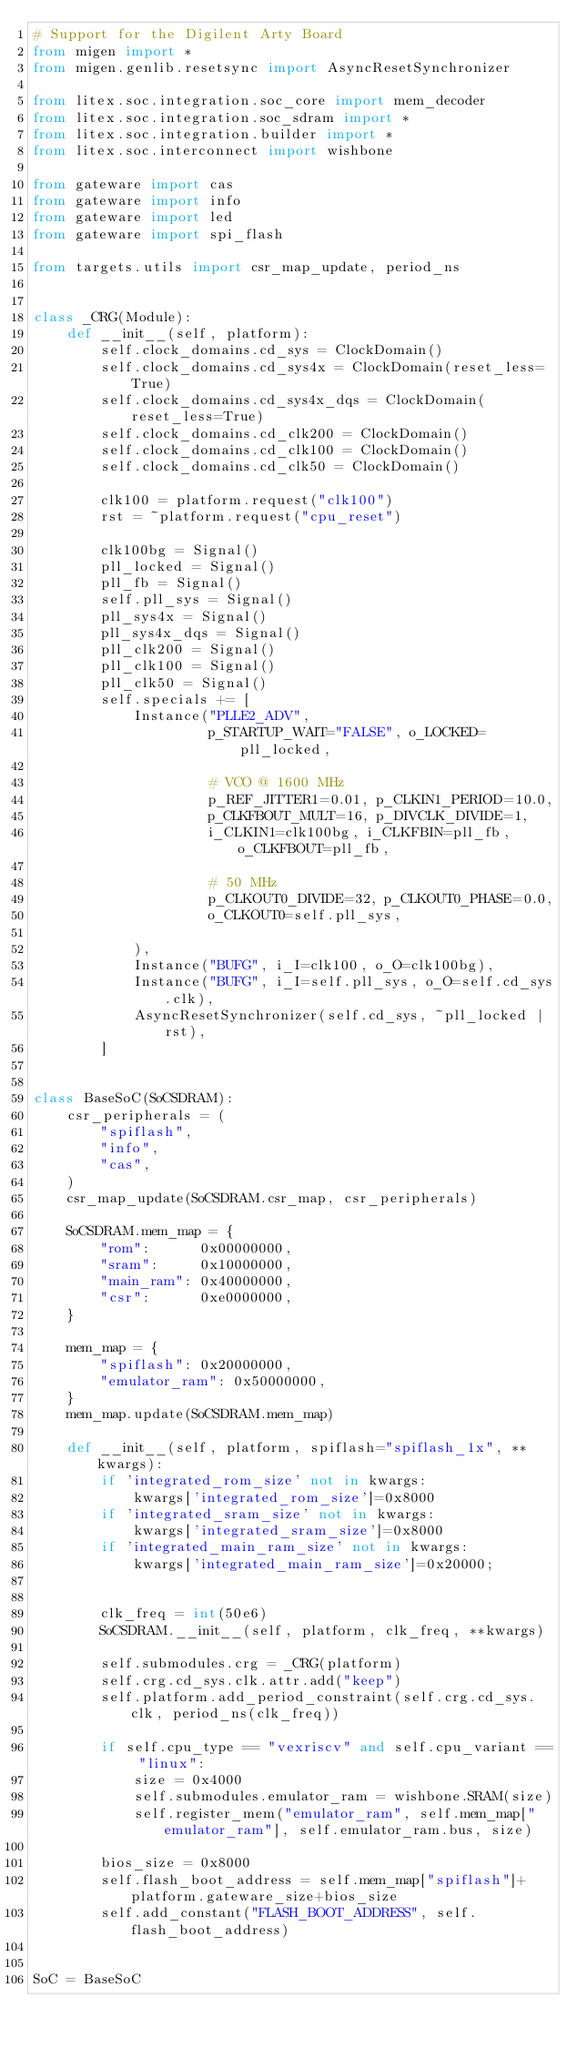<code> <loc_0><loc_0><loc_500><loc_500><_Python_># Support for the Digilent Arty Board
from migen import *
from migen.genlib.resetsync import AsyncResetSynchronizer

from litex.soc.integration.soc_core import mem_decoder
from litex.soc.integration.soc_sdram import *
from litex.soc.integration.builder import *
from litex.soc.interconnect import wishbone

from gateware import cas
from gateware import info
from gateware import led
from gateware import spi_flash

from targets.utils import csr_map_update, period_ns


class _CRG(Module):
    def __init__(self, platform):
        self.clock_domains.cd_sys = ClockDomain()
        self.clock_domains.cd_sys4x = ClockDomain(reset_less=True)
        self.clock_domains.cd_sys4x_dqs = ClockDomain(reset_less=True)
        self.clock_domains.cd_clk200 = ClockDomain()
        self.clock_domains.cd_clk100 = ClockDomain()
        self.clock_domains.cd_clk50 = ClockDomain()

        clk100 = platform.request("clk100")
        rst = ~platform.request("cpu_reset")

        clk100bg = Signal()
        pll_locked = Signal()
        pll_fb = Signal()
        self.pll_sys = Signal()
        pll_sys4x = Signal()
        pll_sys4x_dqs = Signal()
        pll_clk200 = Signal()
        pll_clk100 = Signal()
        pll_clk50 = Signal()
        self.specials += [
            Instance("PLLE2_ADV",
                     p_STARTUP_WAIT="FALSE", o_LOCKED=pll_locked,

                     # VCO @ 1600 MHz
                     p_REF_JITTER1=0.01, p_CLKIN1_PERIOD=10.0,
                     p_CLKFBOUT_MULT=16, p_DIVCLK_DIVIDE=1,
                     i_CLKIN1=clk100bg, i_CLKFBIN=pll_fb, o_CLKFBOUT=pll_fb,

                     # 50 MHz
                     p_CLKOUT0_DIVIDE=32, p_CLKOUT0_PHASE=0.0,
                     o_CLKOUT0=self.pll_sys,

            ),
            Instance("BUFG", i_I=clk100, o_O=clk100bg),
            Instance("BUFG", i_I=self.pll_sys, o_O=self.cd_sys.clk),
            AsyncResetSynchronizer(self.cd_sys, ~pll_locked | rst),
        ]


class BaseSoC(SoCSDRAM):
    csr_peripherals = (
        "spiflash",
        "info",
        "cas",
    )
    csr_map_update(SoCSDRAM.csr_map, csr_peripherals)

    SoCSDRAM.mem_map = {
        "rom":      0x00000000,
        "sram":     0x10000000,
        "main_ram": 0x40000000,
        "csr":      0xe0000000,
    }

    mem_map = {
        "spiflash": 0x20000000,
        "emulator_ram": 0x50000000,
    }
    mem_map.update(SoCSDRAM.mem_map)

    def __init__(self, platform, spiflash="spiflash_1x", **kwargs):
        if 'integrated_rom_size' not in kwargs:
            kwargs['integrated_rom_size']=0x8000
        if 'integrated_sram_size' not in kwargs:
            kwargs['integrated_sram_size']=0x8000
        if 'integrated_main_ram_size' not in kwargs:
            kwargs['integrated_main_ram_size']=0x20000;


        clk_freq = int(50e6)
        SoCSDRAM.__init__(self, platform, clk_freq, **kwargs)

        self.submodules.crg = _CRG(platform)
        self.crg.cd_sys.clk.attr.add("keep")
        self.platform.add_period_constraint(self.crg.cd_sys.clk, period_ns(clk_freq))

        if self.cpu_type == "vexriscv" and self.cpu_variant == "linux":
            size = 0x4000
            self.submodules.emulator_ram = wishbone.SRAM(size)
            self.register_mem("emulator_ram", self.mem_map["emulator_ram"], self.emulator_ram.bus, size)

        bios_size = 0x8000
        self.flash_boot_address = self.mem_map["spiflash"]+platform.gateware_size+bios_size
        self.add_constant("FLASH_BOOT_ADDRESS", self.flash_boot_address)


SoC = BaseSoC
</code> 